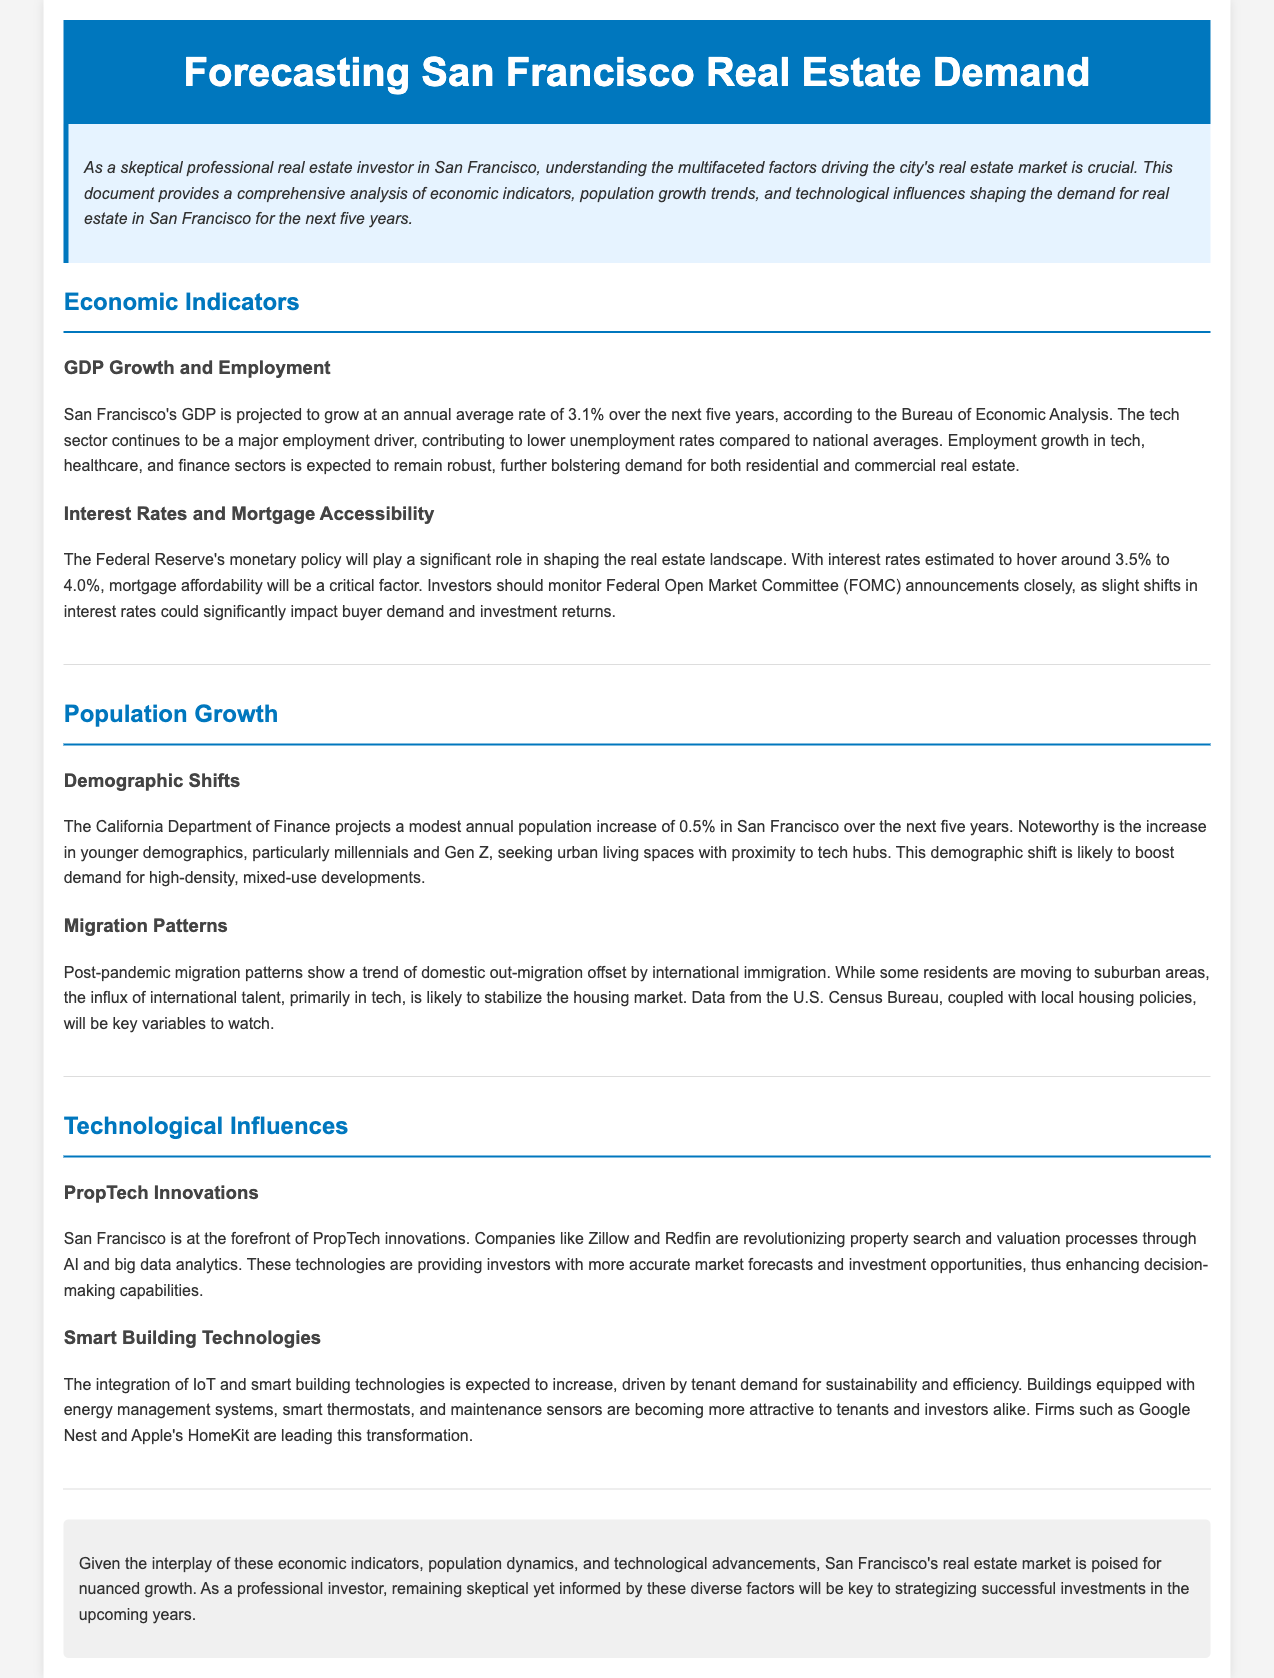what is the projected GDP growth rate for San Francisco? The document states that San Francisco's GDP is projected to grow at an annual average rate of 3.1% over the next five years.
Answer: 3.1% what sectors are expected to see robust employment growth? The document indicates that tech, healthcare, and finance sectors are expected to see robust employment growth.
Answer: Tech, healthcare, and finance what is the estimated range for interest rates mentioned? The document mentions that interest rates are estimated to hover around 3.5% to 4.0%.
Answer: 3.5% to 4.0% how much is the expected annual population increase in San Francisco? The document projects a modest annual population increase of 0.5% in San Francisco.
Answer: 0.5% what demographic is driving demand for high-density developments? The document notes that millennials and Gen Z are driving demand for high-density developments.
Answer: Millennials and Gen Z which technology sector is San Francisco a leader in? The document states that San Francisco is at the forefront of PropTech innovations.
Answer: PropTech what tenant demand is driving smart building technologies? The document mentions that tenant demand for sustainability and efficiency is driving smart building technologies.
Answer: Sustainability and efficiency what is the expected role of international talent in the housing market? The document implies that the influx of international talent is likely to stabilize the housing market.
Answer: Stabilize the housing market what is a key variable to watch according to the migration patterns section? The document indicates that data from the U.S. Census Bureau is a key variable to watch.
Answer: U.S. Census Bureau 